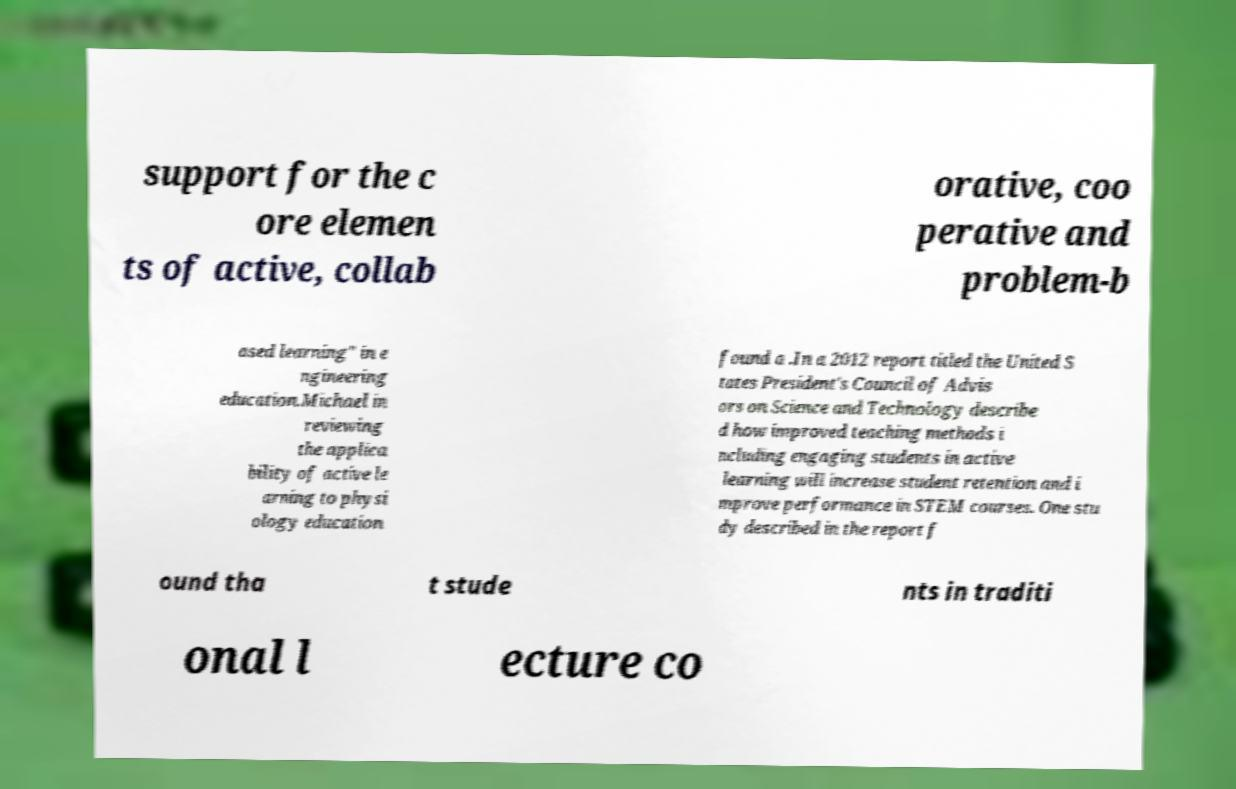Could you assist in decoding the text presented in this image and type it out clearly? support for the c ore elemen ts of active, collab orative, coo perative and problem-b ased learning" in e ngineering education.Michael in reviewing the applica bility of active le arning to physi ology education found a .In a 2012 report titled the United S tates President's Council of Advis ors on Science and Technology describe d how improved teaching methods i ncluding engaging students in active learning will increase student retention and i mprove performance in STEM courses. One stu dy described in the report f ound tha t stude nts in traditi onal l ecture co 